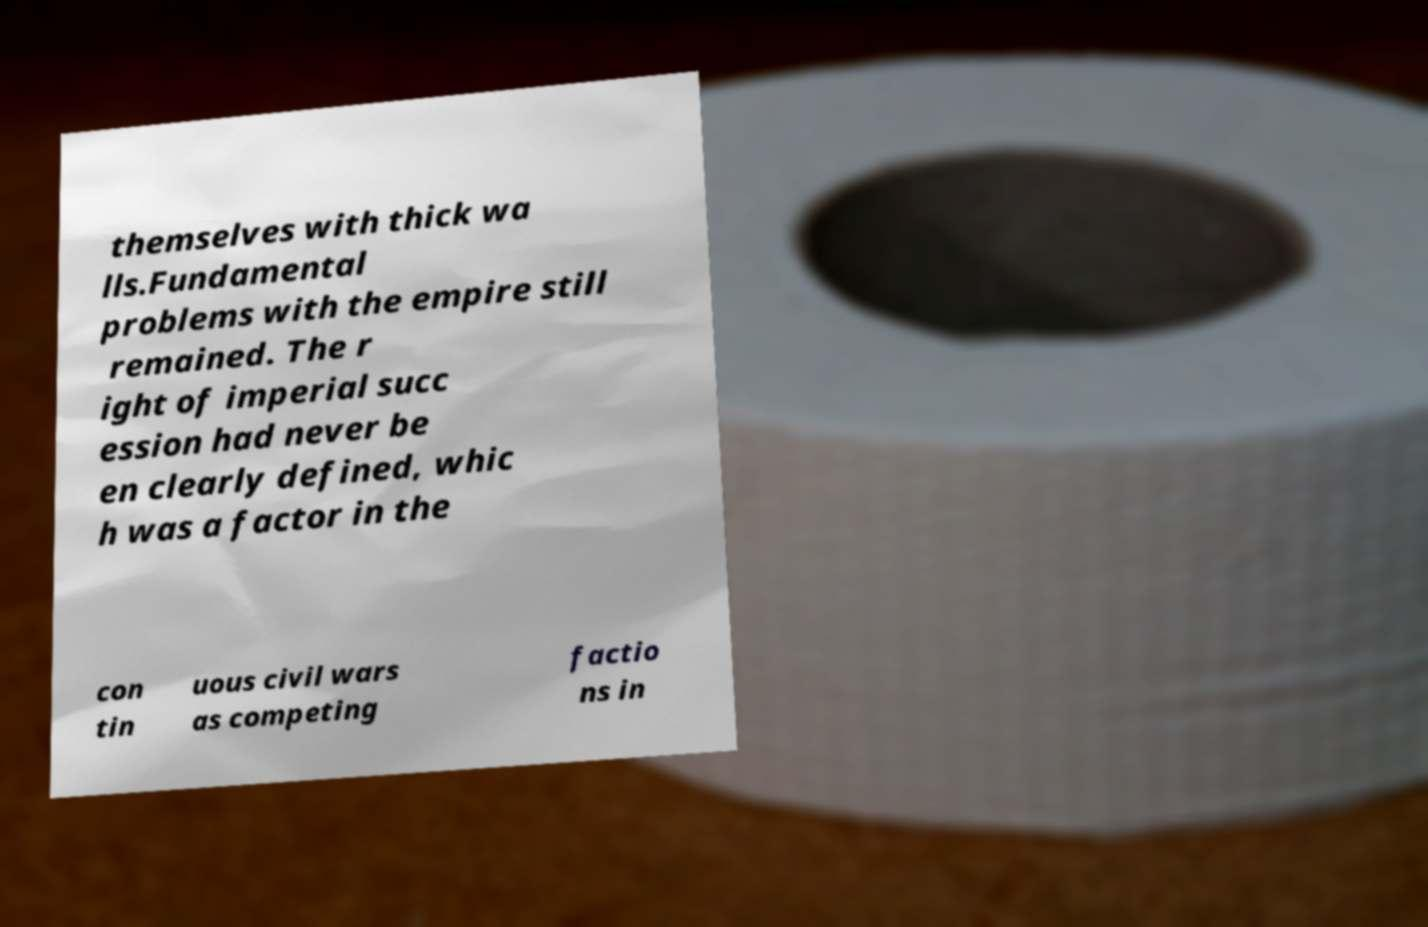Can you accurately transcribe the text from the provided image for me? themselves with thick wa lls.Fundamental problems with the empire still remained. The r ight of imperial succ ession had never be en clearly defined, whic h was a factor in the con tin uous civil wars as competing factio ns in 